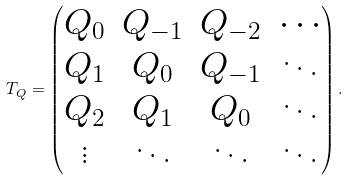<formula> <loc_0><loc_0><loc_500><loc_500>T _ { Q } = \begin{pmatrix} Q _ { 0 } & Q _ { - 1 } & Q _ { - 2 } & \cdots \\ Q _ { 1 } & Q _ { 0 } & Q _ { - 1 } & \ddots \\ Q _ { 2 } & Q _ { 1 } & Q _ { 0 } & \ddots \\ \vdots & \ddots & \ddots & \ddots \end{pmatrix} .</formula> 